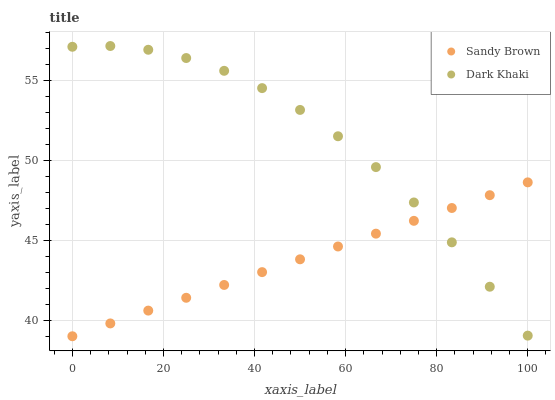Does Sandy Brown have the minimum area under the curve?
Answer yes or no. Yes. Does Dark Khaki have the maximum area under the curve?
Answer yes or no. Yes. Does Sandy Brown have the maximum area under the curve?
Answer yes or no. No. Is Sandy Brown the smoothest?
Answer yes or no. Yes. Is Dark Khaki the roughest?
Answer yes or no. Yes. Is Sandy Brown the roughest?
Answer yes or no. No. Does Sandy Brown have the lowest value?
Answer yes or no. Yes. Does Dark Khaki have the highest value?
Answer yes or no. Yes. Does Sandy Brown have the highest value?
Answer yes or no. No. Does Sandy Brown intersect Dark Khaki?
Answer yes or no. Yes. Is Sandy Brown less than Dark Khaki?
Answer yes or no. No. Is Sandy Brown greater than Dark Khaki?
Answer yes or no. No. 